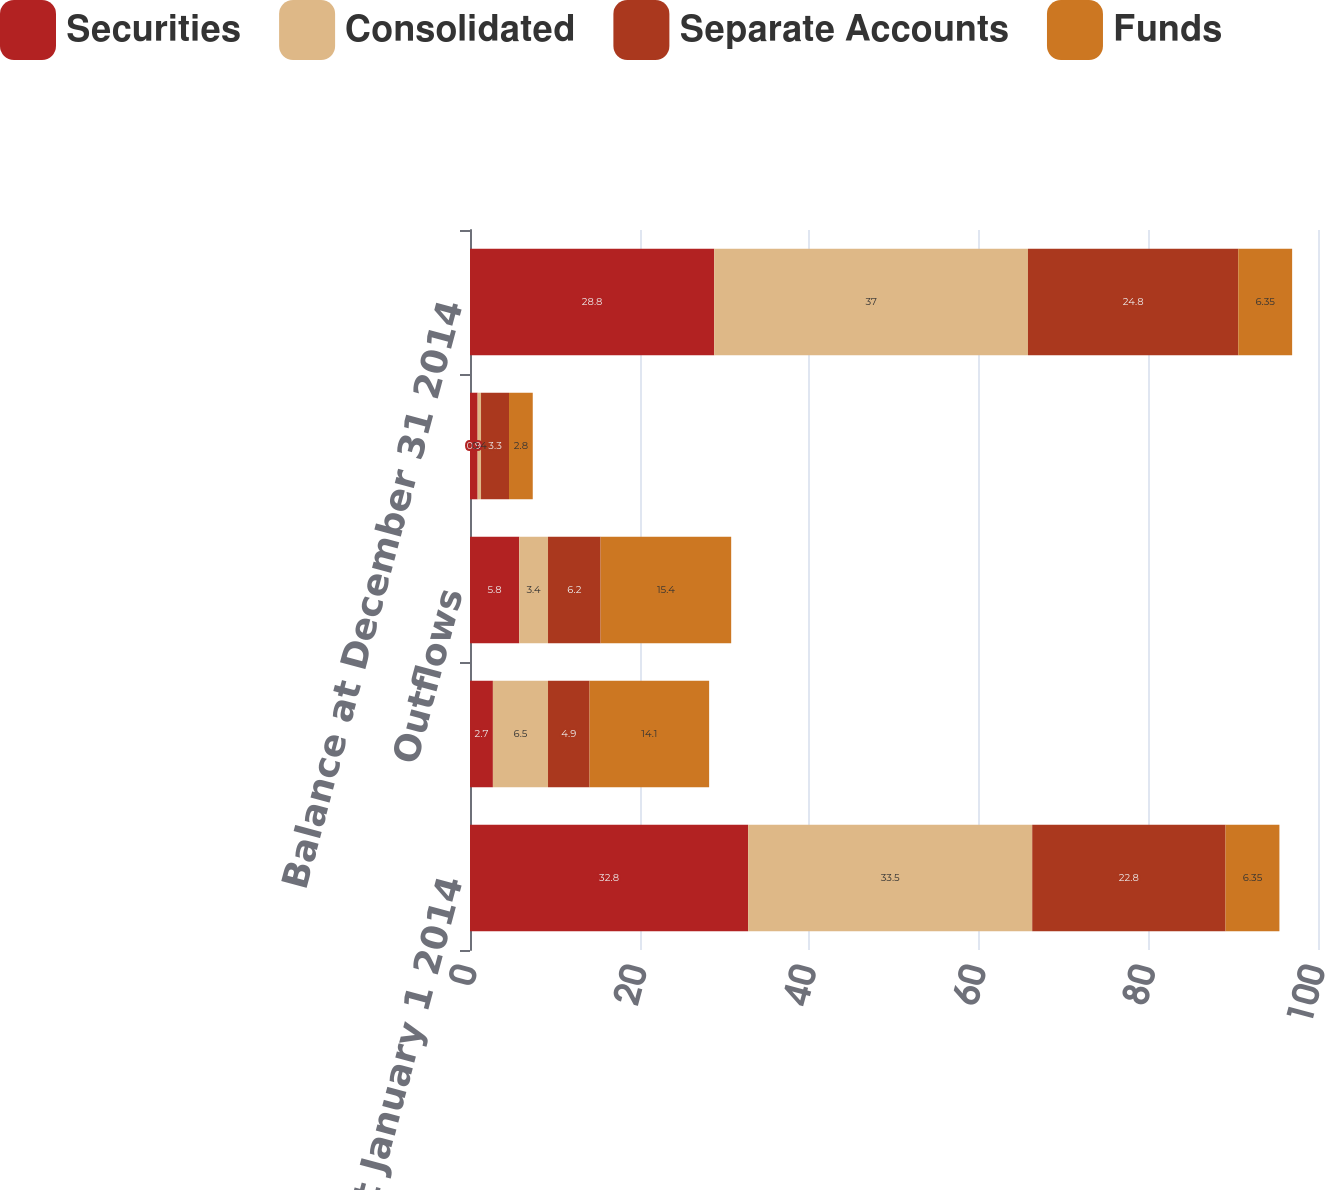Convert chart to OTSL. <chart><loc_0><loc_0><loc_500><loc_500><stacked_bar_chart><ecel><fcel>Balance at January 1 2014<fcel>Inflows<fcel>Outflows<fcel>Market (depreciation)<fcel>Balance at December 31 2014<nl><fcel>Securities<fcel>32.8<fcel>2.7<fcel>5.8<fcel>0.9<fcel>28.8<nl><fcel>Consolidated<fcel>33.5<fcel>6.5<fcel>3.4<fcel>0.4<fcel>37<nl><fcel>Separate Accounts<fcel>22.8<fcel>4.9<fcel>6.2<fcel>3.3<fcel>24.8<nl><fcel>Funds<fcel>6.35<fcel>14.1<fcel>15.4<fcel>2.8<fcel>6.35<nl></chart> 